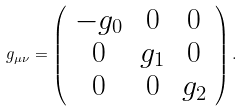<formula> <loc_0><loc_0><loc_500><loc_500>g _ { \mu \nu } = \left ( \begin{array} { c c c } - g _ { 0 } & 0 & 0 \\ 0 & g _ { 1 } & 0 \\ 0 & 0 & g _ { 2 } \end{array} \right ) .</formula> 